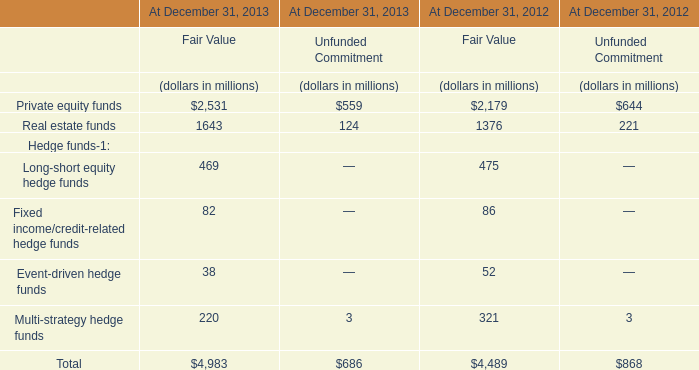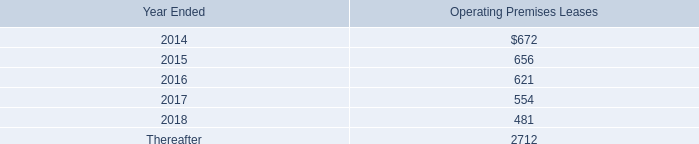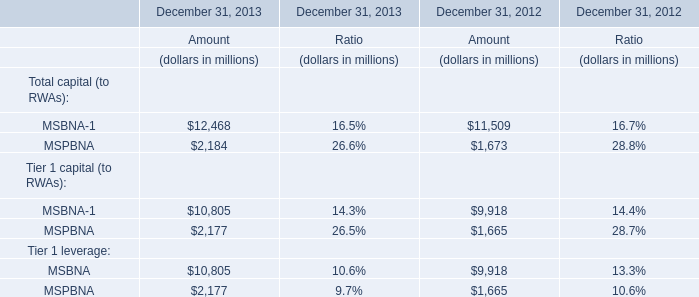If MSBNA-1 for Total capital (to RWAs) develops with the same increasing rate in 2013, what will it reach in 2014? (in million) 
Computations: (12468 * (1 + ((12468 - 11509) / 11509)))
Answer: 13506.90972. 